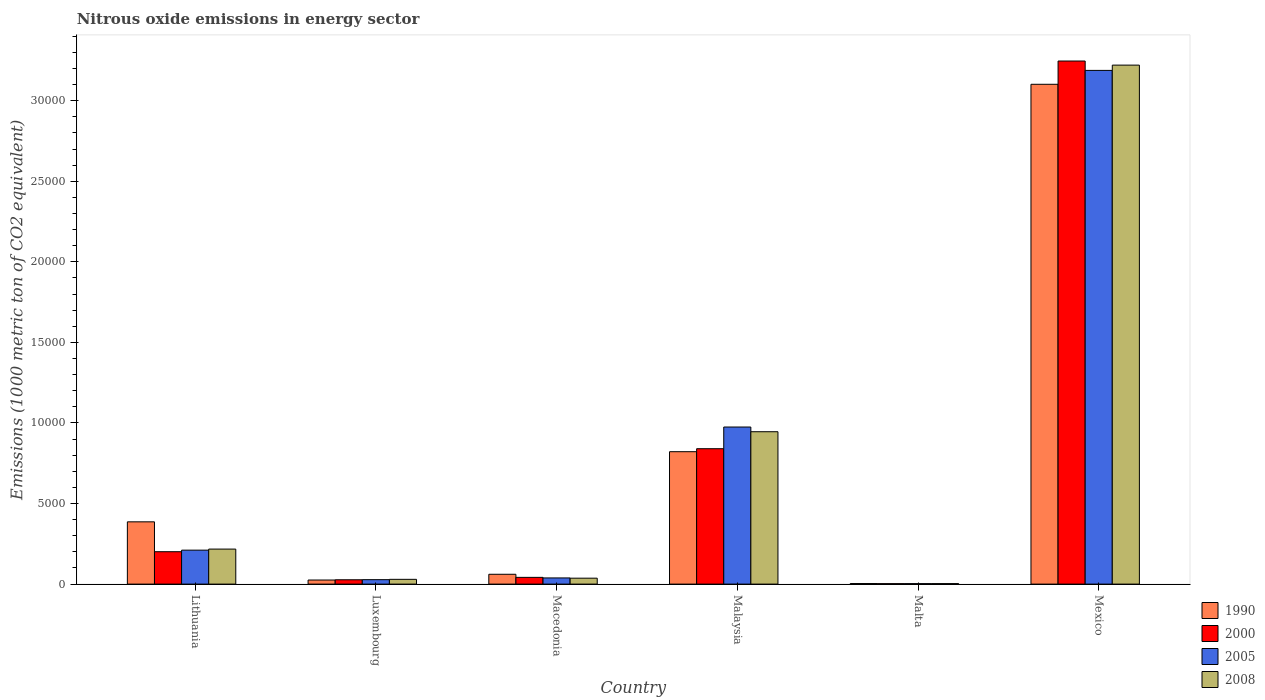How many different coloured bars are there?
Give a very brief answer. 4. In how many cases, is the number of bars for a given country not equal to the number of legend labels?
Your answer should be compact. 0. What is the amount of nitrous oxide emitted in 2000 in Lithuania?
Your answer should be very brief. 2010.8. Across all countries, what is the maximum amount of nitrous oxide emitted in 2005?
Provide a succinct answer. 3.19e+04. Across all countries, what is the minimum amount of nitrous oxide emitted in 2008?
Ensure brevity in your answer.  31.1. In which country was the amount of nitrous oxide emitted in 2008 maximum?
Give a very brief answer. Mexico. In which country was the amount of nitrous oxide emitted in 2008 minimum?
Make the answer very short. Malta. What is the total amount of nitrous oxide emitted in 1990 in the graph?
Make the answer very short. 4.40e+04. What is the difference between the amount of nitrous oxide emitted in 1990 in Malaysia and that in Malta?
Your response must be concise. 8183. What is the difference between the amount of nitrous oxide emitted in 2008 in Malaysia and the amount of nitrous oxide emitted in 1990 in Malta?
Offer a terse response. 9422.6. What is the average amount of nitrous oxide emitted in 2008 per country?
Make the answer very short. 7423.28. What is the difference between the amount of nitrous oxide emitted of/in 2008 and amount of nitrous oxide emitted of/in 2000 in Malaysia?
Offer a very short reply. 1054.4. In how many countries, is the amount of nitrous oxide emitted in 2005 greater than 20000 1000 metric ton?
Your response must be concise. 1. What is the ratio of the amount of nitrous oxide emitted in 2005 in Lithuania to that in Mexico?
Make the answer very short. 0.07. What is the difference between the highest and the second highest amount of nitrous oxide emitted in 1990?
Your response must be concise. -4353. What is the difference between the highest and the lowest amount of nitrous oxide emitted in 2000?
Your answer should be very brief. 3.24e+04. Is it the case that in every country, the sum of the amount of nitrous oxide emitted in 2008 and amount of nitrous oxide emitted in 2000 is greater than the sum of amount of nitrous oxide emitted in 2005 and amount of nitrous oxide emitted in 1990?
Ensure brevity in your answer.  No. What does the 1st bar from the left in Malaysia represents?
Your response must be concise. 1990. What does the 3rd bar from the right in Macedonia represents?
Your response must be concise. 2000. Is it the case that in every country, the sum of the amount of nitrous oxide emitted in 2008 and amount of nitrous oxide emitted in 1990 is greater than the amount of nitrous oxide emitted in 2005?
Your response must be concise. Yes. How many bars are there?
Provide a short and direct response. 24. Are all the bars in the graph horizontal?
Your answer should be compact. No. What is the difference between two consecutive major ticks on the Y-axis?
Provide a succinct answer. 5000. Are the values on the major ticks of Y-axis written in scientific E-notation?
Keep it short and to the point. No. Where does the legend appear in the graph?
Keep it short and to the point. Bottom right. How many legend labels are there?
Your answer should be very brief. 4. How are the legend labels stacked?
Provide a short and direct response. Vertical. What is the title of the graph?
Your answer should be compact. Nitrous oxide emissions in energy sector. What is the label or title of the X-axis?
Provide a short and direct response. Country. What is the label or title of the Y-axis?
Make the answer very short. Emissions (1000 metric ton of CO2 equivalent). What is the Emissions (1000 metric ton of CO2 equivalent) in 1990 in Lithuania?
Give a very brief answer. 3865. What is the Emissions (1000 metric ton of CO2 equivalent) of 2000 in Lithuania?
Your response must be concise. 2010.8. What is the Emissions (1000 metric ton of CO2 equivalent) in 2005 in Lithuania?
Provide a succinct answer. 2107. What is the Emissions (1000 metric ton of CO2 equivalent) of 2008 in Lithuania?
Offer a terse response. 2173.9. What is the Emissions (1000 metric ton of CO2 equivalent) of 1990 in Luxembourg?
Your response must be concise. 253.6. What is the Emissions (1000 metric ton of CO2 equivalent) in 2000 in Luxembourg?
Your answer should be compact. 268.4. What is the Emissions (1000 metric ton of CO2 equivalent) of 2005 in Luxembourg?
Your answer should be very brief. 275.3. What is the Emissions (1000 metric ton of CO2 equivalent) in 2008 in Luxembourg?
Your answer should be very brief. 296.2. What is the Emissions (1000 metric ton of CO2 equivalent) in 1990 in Macedonia?
Your answer should be very brief. 610.4. What is the Emissions (1000 metric ton of CO2 equivalent) of 2000 in Macedonia?
Your answer should be very brief. 418.3. What is the Emissions (1000 metric ton of CO2 equivalent) of 2005 in Macedonia?
Give a very brief answer. 382.8. What is the Emissions (1000 metric ton of CO2 equivalent) of 2008 in Macedonia?
Your answer should be very brief. 368. What is the Emissions (1000 metric ton of CO2 equivalent) in 1990 in Malaysia?
Keep it short and to the point. 8218. What is the Emissions (1000 metric ton of CO2 equivalent) of 2000 in Malaysia?
Ensure brevity in your answer.  8403.2. What is the Emissions (1000 metric ton of CO2 equivalent) of 2005 in Malaysia?
Your answer should be very brief. 9749.3. What is the Emissions (1000 metric ton of CO2 equivalent) of 2008 in Malaysia?
Your answer should be very brief. 9457.6. What is the Emissions (1000 metric ton of CO2 equivalent) of 1990 in Malta?
Offer a terse response. 35. What is the Emissions (1000 metric ton of CO2 equivalent) in 2000 in Malta?
Provide a succinct answer. 28.2. What is the Emissions (1000 metric ton of CO2 equivalent) in 2005 in Malta?
Provide a short and direct response. 28.7. What is the Emissions (1000 metric ton of CO2 equivalent) of 2008 in Malta?
Keep it short and to the point. 31.1. What is the Emissions (1000 metric ton of CO2 equivalent) of 1990 in Mexico?
Make the answer very short. 3.10e+04. What is the Emissions (1000 metric ton of CO2 equivalent) of 2000 in Mexico?
Your response must be concise. 3.25e+04. What is the Emissions (1000 metric ton of CO2 equivalent) of 2005 in Mexico?
Your answer should be compact. 3.19e+04. What is the Emissions (1000 metric ton of CO2 equivalent) of 2008 in Mexico?
Give a very brief answer. 3.22e+04. Across all countries, what is the maximum Emissions (1000 metric ton of CO2 equivalent) in 1990?
Your answer should be very brief. 3.10e+04. Across all countries, what is the maximum Emissions (1000 metric ton of CO2 equivalent) in 2000?
Give a very brief answer. 3.25e+04. Across all countries, what is the maximum Emissions (1000 metric ton of CO2 equivalent) in 2005?
Give a very brief answer. 3.19e+04. Across all countries, what is the maximum Emissions (1000 metric ton of CO2 equivalent) of 2008?
Keep it short and to the point. 3.22e+04. Across all countries, what is the minimum Emissions (1000 metric ton of CO2 equivalent) in 2000?
Make the answer very short. 28.2. Across all countries, what is the minimum Emissions (1000 metric ton of CO2 equivalent) of 2005?
Keep it short and to the point. 28.7. Across all countries, what is the minimum Emissions (1000 metric ton of CO2 equivalent) of 2008?
Offer a very short reply. 31.1. What is the total Emissions (1000 metric ton of CO2 equivalent) of 1990 in the graph?
Keep it short and to the point. 4.40e+04. What is the total Emissions (1000 metric ton of CO2 equivalent) in 2000 in the graph?
Your answer should be compact. 4.36e+04. What is the total Emissions (1000 metric ton of CO2 equivalent) in 2005 in the graph?
Your answer should be compact. 4.44e+04. What is the total Emissions (1000 metric ton of CO2 equivalent) of 2008 in the graph?
Provide a succinct answer. 4.45e+04. What is the difference between the Emissions (1000 metric ton of CO2 equivalent) of 1990 in Lithuania and that in Luxembourg?
Keep it short and to the point. 3611.4. What is the difference between the Emissions (1000 metric ton of CO2 equivalent) in 2000 in Lithuania and that in Luxembourg?
Give a very brief answer. 1742.4. What is the difference between the Emissions (1000 metric ton of CO2 equivalent) in 2005 in Lithuania and that in Luxembourg?
Provide a succinct answer. 1831.7. What is the difference between the Emissions (1000 metric ton of CO2 equivalent) in 2008 in Lithuania and that in Luxembourg?
Your response must be concise. 1877.7. What is the difference between the Emissions (1000 metric ton of CO2 equivalent) in 1990 in Lithuania and that in Macedonia?
Your answer should be compact. 3254.6. What is the difference between the Emissions (1000 metric ton of CO2 equivalent) of 2000 in Lithuania and that in Macedonia?
Ensure brevity in your answer.  1592.5. What is the difference between the Emissions (1000 metric ton of CO2 equivalent) of 2005 in Lithuania and that in Macedonia?
Keep it short and to the point. 1724.2. What is the difference between the Emissions (1000 metric ton of CO2 equivalent) of 2008 in Lithuania and that in Macedonia?
Provide a succinct answer. 1805.9. What is the difference between the Emissions (1000 metric ton of CO2 equivalent) in 1990 in Lithuania and that in Malaysia?
Offer a very short reply. -4353. What is the difference between the Emissions (1000 metric ton of CO2 equivalent) in 2000 in Lithuania and that in Malaysia?
Provide a succinct answer. -6392.4. What is the difference between the Emissions (1000 metric ton of CO2 equivalent) of 2005 in Lithuania and that in Malaysia?
Give a very brief answer. -7642.3. What is the difference between the Emissions (1000 metric ton of CO2 equivalent) in 2008 in Lithuania and that in Malaysia?
Provide a short and direct response. -7283.7. What is the difference between the Emissions (1000 metric ton of CO2 equivalent) in 1990 in Lithuania and that in Malta?
Your answer should be very brief. 3830. What is the difference between the Emissions (1000 metric ton of CO2 equivalent) of 2000 in Lithuania and that in Malta?
Offer a terse response. 1982.6. What is the difference between the Emissions (1000 metric ton of CO2 equivalent) in 2005 in Lithuania and that in Malta?
Your response must be concise. 2078.3. What is the difference between the Emissions (1000 metric ton of CO2 equivalent) in 2008 in Lithuania and that in Malta?
Your answer should be compact. 2142.8. What is the difference between the Emissions (1000 metric ton of CO2 equivalent) of 1990 in Lithuania and that in Mexico?
Ensure brevity in your answer.  -2.72e+04. What is the difference between the Emissions (1000 metric ton of CO2 equivalent) of 2000 in Lithuania and that in Mexico?
Give a very brief answer. -3.05e+04. What is the difference between the Emissions (1000 metric ton of CO2 equivalent) in 2005 in Lithuania and that in Mexico?
Give a very brief answer. -2.98e+04. What is the difference between the Emissions (1000 metric ton of CO2 equivalent) in 2008 in Lithuania and that in Mexico?
Ensure brevity in your answer.  -3.00e+04. What is the difference between the Emissions (1000 metric ton of CO2 equivalent) in 1990 in Luxembourg and that in Macedonia?
Make the answer very short. -356.8. What is the difference between the Emissions (1000 metric ton of CO2 equivalent) of 2000 in Luxembourg and that in Macedonia?
Offer a terse response. -149.9. What is the difference between the Emissions (1000 metric ton of CO2 equivalent) in 2005 in Luxembourg and that in Macedonia?
Offer a very short reply. -107.5. What is the difference between the Emissions (1000 metric ton of CO2 equivalent) of 2008 in Luxembourg and that in Macedonia?
Ensure brevity in your answer.  -71.8. What is the difference between the Emissions (1000 metric ton of CO2 equivalent) in 1990 in Luxembourg and that in Malaysia?
Provide a short and direct response. -7964.4. What is the difference between the Emissions (1000 metric ton of CO2 equivalent) in 2000 in Luxembourg and that in Malaysia?
Provide a succinct answer. -8134.8. What is the difference between the Emissions (1000 metric ton of CO2 equivalent) of 2005 in Luxembourg and that in Malaysia?
Your response must be concise. -9474. What is the difference between the Emissions (1000 metric ton of CO2 equivalent) in 2008 in Luxembourg and that in Malaysia?
Provide a short and direct response. -9161.4. What is the difference between the Emissions (1000 metric ton of CO2 equivalent) of 1990 in Luxembourg and that in Malta?
Your answer should be very brief. 218.6. What is the difference between the Emissions (1000 metric ton of CO2 equivalent) in 2000 in Luxembourg and that in Malta?
Offer a terse response. 240.2. What is the difference between the Emissions (1000 metric ton of CO2 equivalent) in 2005 in Luxembourg and that in Malta?
Provide a succinct answer. 246.6. What is the difference between the Emissions (1000 metric ton of CO2 equivalent) of 2008 in Luxembourg and that in Malta?
Offer a very short reply. 265.1. What is the difference between the Emissions (1000 metric ton of CO2 equivalent) in 1990 in Luxembourg and that in Mexico?
Your answer should be compact. -3.08e+04. What is the difference between the Emissions (1000 metric ton of CO2 equivalent) in 2000 in Luxembourg and that in Mexico?
Your answer should be very brief. -3.22e+04. What is the difference between the Emissions (1000 metric ton of CO2 equivalent) in 2005 in Luxembourg and that in Mexico?
Give a very brief answer. -3.16e+04. What is the difference between the Emissions (1000 metric ton of CO2 equivalent) in 2008 in Luxembourg and that in Mexico?
Offer a very short reply. -3.19e+04. What is the difference between the Emissions (1000 metric ton of CO2 equivalent) of 1990 in Macedonia and that in Malaysia?
Make the answer very short. -7607.6. What is the difference between the Emissions (1000 metric ton of CO2 equivalent) in 2000 in Macedonia and that in Malaysia?
Your answer should be very brief. -7984.9. What is the difference between the Emissions (1000 metric ton of CO2 equivalent) in 2005 in Macedonia and that in Malaysia?
Your answer should be compact. -9366.5. What is the difference between the Emissions (1000 metric ton of CO2 equivalent) of 2008 in Macedonia and that in Malaysia?
Provide a succinct answer. -9089.6. What is the difference between the Emissions (1000 metric ton of CO2 equivalent) of 1990 in Macedonia and that in Malta?
Offer a terse response. 575.4. What is the difference between the Emissions (1000 metric ton of CO2 equivalent) of 2000 in Macedonia and that in Malta?
Provide a short and direct response. 390.1. What is the difference between the Emissions (1000 metric ton of CO2 equivalent) of 2005 in Macedonia and that in Malta?
Keep it short and to the point. 354.1. What is the difference between the Emissions (1000 metric ton of CO2 equivalent) of 2008 in Macedonia and that in Malta?
Offer a terse response. 336.9. What is the difference between the Emissions (1000 metric ton of CO2 equivalent) of 1990 in Macedonia and that in Mexico?
Make the answer very short. -3.04e+04. What is the difference between the Emissions (1000 metric ton of CO2 equivalent) in 2000 in Macedonia and that in Mexico?
Ensure brevity in your answer.  -3.20e+04. What is the difference between the Emissions (1000 metric ton of CO2 equivalent) of 2005 in Macedonia and that in Mexico?
Your answer should be very brief. -3.15e+04. What is the difference between the Emissions (1000 metric ton of CO2 equivalent) of 2008 in Macedonia and that in Mexico?
Your answer should be compact. -3.18e+04. What is the difference between the Emissions (1000 metric ton of CO2 equivalent) of 1990 in Malaysia and that in Malta?
Offer a terse response. 8183. What is the difference between the Emissions (1000 metric ton of CO2 equivalent) in 2000 in Malaysia and that in Malta?
Your answer should be compact. 8375. What is the difference between the Emissions (1000 metric ton of CO2 equivalent) of 2005 in Malaysia and that in Malta?
Provide a short and direct response. 9720.6. What is the difference between the Emissions (1000 metric ton of CO2 equivalent) in 2008 in Malaysia and that in Malta?
Provide a short and direct response. 9426.5. What is the difference between the Emissions (1000 metric ton of CO2 equivalent) in 1990 in Malaysia and that in Mexico?
Offer a very short reply. -2.28e+04. What is the difference between the Emissions (1000 metric ton of CO2 equivalent) in 2000 in Malaysia and that in Mexico?
Provide a short and direct response. -2.41e+04. What is the difference between the Emissions (1000 metric ton of CO2 equivalent) of 2005 in Malaysia and that in Mexico?
Make the answer very short. -2.21e+04. What is the difference between the Emissions (1000 metric ton of CO2 equivalent) of 2008 in Malaysia and that in Mexico?
Give a very brief answer. -2.28e+04. What is the difference between the Emissions (1000 metric ton of CO2 equivalent) of 1990 in Malta and that in Mexico?
Your answer should be compact. -3.10e+04. What is the difference between the Emissions (1000 metric ton of CO2 equivalent) of 2000 in Malta and that in Mexico?
Your answer should be very brief. -3.24e+04. What is the difference between the Emissions (1000 metric ton of CO2 equivalent) of 2005 in Malta and that in Mexico?
Provide a succinct answer. -3.19e+04. What is the difference between the Emissions (1000 metric ton of CO2 equivalent) in 2008 in Malta and that in Mexico?
Make the answer very short. -3.22e+04. What is the difference between the Emissions (1000 metric ton of CO2 equivalent) in 1990 in Lithuania and the Emissions (1000 metric ton of CO2 equivalent) in 2000 in Luxembourg?
Provide a succinct answer. 3596.6. What is the difference between the Emissions (1000 metric ton of CO2 equivalent) in 1990 in Lithuania and the Emissions (1000 metric ton of CO2 equivalent) in 2005 in Luxembourg?
Offer a very short reply. 3589.7. What is the difference between the Emissions (1000 metric ton of CO2 equivalent) in 1990 in Lithuania and the Emissions (1000 metric ton of CO2 equivalent) in 2008 in Luxembourg?
Your answer should be compact. 3568.8. What is the difference between the Emissions (1000 metric ton of CO2 equivalent) of 2000 in Lithuania and the Emissions (1000 metric ton of CO2 equivalent) of 2005 in Luxembourg?
Ensure brevity in your answer.  1735.5. What is the difference between the Emissions (1000 metric ton of CO2 equivalent) in 2000 in Lithuania and the Emissions (1000 metric ton of CO2 equivalent) in 2008 in Luxembourg?
Your response must be concise. 1714.6. What is the difference between the Emissions (1000 metric ton of CO2 equivalent) in 2005 in Lithuania and the Emissions (1000 metric ton of CO2 equivalent) in 2008 in Luxembourg?
Provide a short and direct response. 1810.8. What is the difference between the Emissions (1000 metric ton of CO2 equivalent) of 1990 in Lithuania and the Emissions (1000 metric ton of CO2 equivalent) of 2000 in Macedonia?
Keep it short and to the point. 3446.7. What is the difference between the Emissions (1000 metric ton of CO2 equivalent) in 1990 in Lithuania and the Emissions (1000 metric ton of CO2 equivalent) in 2005 in Macedonia?
Keep it short and to the point. 3482.2. What is the difference between the Emissions (1000 metric ton of CO2 equivalent) in 1990 in Lithuania and the Emissions (1000 metric ton of CO2 equivalent) in 2008 in Macedonia?
Offer a terse response. 3497. What is the difference between the Emissions (1000 metric ton of CO2 equivalent) of 2000 in Lithuania and the Emissions (1000 metric ton of CO2 equivalent) of 2005 in Macedonia?
Offer a very short reply. 1628. What is the difference between the Emissions (1000 metric ton of CO2 equivalent) in 2000 in Lithuania and the Emissions (1000 metric ton of CO2 equivalent) in 2008 in Macedonia?
Provide a short and direct response. 1642.8. What is the difference between the Emissions (1000 metric ton of CO2 equivalent) in 2005 in Lithuania and the Emissions (1000 metric ton of CO2 equivalent) in 2008 in Macedonia?
Offer a terse response. 1739. What is the difference between the Emissions (1000 metric ton of CO2 equivalent) of 1990 in Lithuania and the Emissions (1000 metric ton of CO2 equivalent) of 2000 in Malaysia?
Offer a very short reply. -4538.2. What is the difference between the Emissions (1000 metric ton of CO2 equivalent) in 1990 in Lithuania and the Emissions (1000 metric ton of CO2 equivalent) in 2005 in Malaysia?
Your answer should be very brief. -5884.3. What is the difference between the Emissions (1000 metric ton of CO2 equivalent) of 1990 in Lithuania and the Emissions (1000 metric ton of CO2 equivalent) of 2008 in Malaysia?
Offer a terse response. -5592.6. What is the difference between the Emissions (1000 metric ton of CO2 equivalent) of 2000 in Lithuania and the Emissions (1000 metric ton of CO2 equivalent) of 2005 in Malaysia?
Your answer should be compact. -7738.5. What is the difference between the Emissions (1000 metric ton of CO2 equivalent) of 2000 in Lithuania and the Emissions (1000 metric ton of CO2 equivalent) of 2008 in Malaysia?
Provide a short and direct response. -7446.8. What is the difference between the Emissions (1000 metric ton of CO2 equivalent) in 2005 in Lithuania and the Emissions (1000 metric ton of CO2 equivalent) in 2008 in Malaysia?
Your answer should be very brief. -7350.6. What is the difference between the Emissions (1000 metric ton of CO2 equivalent) in 1990 in Lithuania and the Emissions (1000 metric ton of CO2 equivalent) in 2000 in Malta?
Offer a very short reply. 3836.8. What is the difference between the Emissions (1000 metric ton of CO2 equivalent) in 1990 in Lithuania and the Emissions (1000 metric ton of CO2 equivalent) in 2005 in Malta?
Provide a short and direct response. 3836.3. What is the difference between the Emissions (1000 metric ton of CO2 equivalent) in 1990 in Lithuania and the Emissions (1000 metric ton of CO2 equivalent) in 2008 in Malta?
Your answer should be compact. 3833.9. What is the difference between the Emissions (1000 metric ton of CO2 equivalent) in 2000 in Lithuania and the Emissions (1000 metric ton of CO2 equivalent) in 2005 in Malta?
Keep it short and to the point. 1982.1. What is the difference between the Emissions (1000 metric ton of CO2 equivalent) in 2000 in Lithuania and the Emissions (1000 metric ton of CO2 equivalent) in 2008 in Malta?
Provide a short and direct response. 1979.7. What is the difference between the Emissions (1000 metric ton of CO2 equivalent) in 2005 in Lithuania and the Emissions (1000 metric ton of CO2 equivalent) in 2008 in Malta?
Give a very brief answer. 2075.9. What is the difference between the Emissions (1000 metric ton of CO2 equivalent) in 1990 in Lithuania and the Emissions (1000 metric ton of CO2 equivalent) in 2000 in Mexico?
Keep it short and to the point. -2.86e+04. What is the difference between the Emissions (1000 metric ton of CO2 equivalent) of 1990 in Lithuania and the Emissions (1000 metric ton of CO2 equivalent) of 2005 in Mexico?
Keep it short and to the point. -2.80e+04. What is the difference between the Emissions (1000 metric ton of CO2 equivalent) in 1990 in Lithuania and the Emissions (1000 metric ton of CO2 equivalent) in 2008 in Mexico?
Provide a succinct answer. -2.83e+04. What is the difference between the Emissions (1000 metric ton of CO2 equivalent) in 2000 in Lithuania and the Emissions (1000 metric ton of CO2 equivalent) in 2005 in Mexico?
Provide a succinct answer. -2.99e+04. What is the difference between the Emissions (1000 metric ton of CO2 equivalent) in 2000 in Lithuania and the Emissions (1000 metric ton of CO2 equivalent) in 2008 in Mexico?
Make the answer very short. -3.02e+04. What is the difference between the Emissions (1000 metric ton of CO2 equivalent) in 2005 in Lithuania and the Emissions (1000 metric ton of CO2 equivalent) in 2008 in Mexico?
Give a very brief answer. -3.01e+04. What is the difference between the Emissions (1000 metric ton of CO2 equivalent) of 1990 in Luxembourg and the Emissions (1000 metric ton of CO2 equivalent) of 2000 in Macedonia?
Keep it short and to the point. -164.7. What is the difference between the Emissions (1000 metric ton of CO2 equivalent) in 1990 in Luxembourg and the Emissions (1000 metric ton of CO2 equivalent) in 2005 in Macedonia?
Keep it short and to the point. -129.2. What is the difference between the Emissions (1000 metric ton of CO2 equivalent) of 1990 in Luxembourg and the Emissions (1000 metric ton of CO2 equivalent) of 2008 in Macedonia?
Your answer should be compact. -114.4. What is the difference between the Emissions (1000 metric ton of CO2 equivalent) of 2000 in Luxembourg and the Emissions (1000 metric ton of CO2 equivalent) of 2005 in Macedonia?
Your answer should be very brief. -114.4. What is the difference between the Emissions (1000 metric ton of CO2 equivalent) in 2000 in Luxembourg and the Emissions (1000 metric ton of CO2 equivalent) in 2008 in Macedonia?
Your answer should be compact. -99.6. What is the difference between the Emissions (1000 metric ton of CO2 equivalent) in 2005 in Luxembourg and the Emissions (1000 metric ton of CO2 equivalent) in 2008 in Macedonia?
Offer a terse response. -92.7. What is the difference between the Emissions (1000 metric ton of CO2 equivalent) of 1990 in Luxembourg and the Emissions (1000 metric ton of CO2 equivalent) of 2000 in Malaysia?
Give a very brief answer. -8149.6. What is the difference between the Emissions (1000 metric ton of CO2 equivalent) in 1990 in Luxembourg and the Emissions (1000 metric ton of CO2 equivalent) in 2005 in Malaysia?
Offer a terse response. -9495.7. What is the difference between the Emissions (1000 metric ton of CO2 equivalent) of 1990 in Luxembourg and the Emissions (1000 metric ton of CO2 equivalent) of 2008 in Malaysia?
Give a very brief answer. -9204. What is the difference between the Emissions (1000 metric ton of CO2 equivalent) in 2000 in Luxembourg and the Emissions (1000 metric ton of CO2 equivalent) in 2005 in Malaysia?
Make the answer very short. -9480.9. What is the difference between the Emissions (1000 metric ton of CO2 equivalent) in 2000 in Luxembourg and the Emissions (1000 metric ton of CO2 equivalent) in 2008 in Malaysia?
Make the answer very short. -9189.2. What is the difference between the Emissions (1000 metric ton of CO2 equivalent) in 2005 in Luxembourg and the Emissions (1000 metric ton of CO2 equivalent) in 2008 in Malaysia?
Provide a succinct answer. -9182.3. What is the difference between the Emissions (1000 metric ton of CO2 equivalent) in 1990 in Luxembourg and the Emissions (1000 metric ton of CO2 equivalent) in 2000 in Malta?
Give a very brief answer. 225.4. What is the difference between the Emissions (1000 metric ton of CO2 equivalent) in 1990 in Luxembourg and the Emissions (1000 metric ton of CO2 equivalent) in 2005 in Malta?
Provide a succinct answer. 224.9. What is the difference between the Emissions (1000 metric ton of CO2 equivalent) in 1990 in Luxembourg and the Emissions (1000 metric ton of CO2 equivalent) in 2008 in Malta?
Your response must be concise. 222.5. What is the difference between the Emissions (1000 metric ton of CO2 equivalent) in 2000 in Luxembourg and the Emissions (1000 metric ton of CO2 equivalent) in 2005 in Malta?
Offer a very short reply. 239.7. What is the difference between the Emissions (1000 metric ton of CO2 equivalent) of 2000 in Luxembourg and the Emissions (1000 metric ton of CO2 equivalent) of 2008 in Malta?
Offer a very short reply. 237.3. What is the difference between the Emissions (1000 metric ton of CO2 equivalent) in 2005 in Luxembourg and the Emissions (1000 metric ton of CO2 equivalent) in 2008 in Malta?
Keep it short and to the point. 244.2. What is the difference between the Emissions (1000 metric ton of CO2 equivalent) in 1990 in Luxembourg and the Emissions (1000 metric ton of CO2 equivalent) in 2000 in Mexico?
Your answer should be very brief. -3.22e+04. What is the difference between the Emissions (1000 metric ton of CO2 equivalent) of 1990 in Luxembourg and the Emissions (1000 metric ton of CO2 equivalent) of 2005 in Mexico?
Offer a very short reply. -3.16e+04. What is the difference between the Emissions (1000 metric ton of CO2 equivalent) of 1990 in Luxembourg and the Emissions (1000 metric ton of CO2 equivalent) of 2008 in Mexico?
Give a very brief answer. -3.20e+04. What is the difference between the Emissions (1000 metric ton of CO2 equivalent) in 2000 in Luxembourg and the Emissions (1000 metric ton of CO2 equivalent) in 2005 in Mexico?
Provide a succinct answer. -3.16e+04. What is the difference between the Emissions (1000 metric ton of CO2 equivalent) of 2000 in Luxembourg and the Emissions (1000 metric ton of CO2 equivalent) of 2008 in Mexico?
Your answer should be very brief. -3.19e+04. What is the difference between the Emissions (1000 metric ton of CO2 equivalent) in 2005 in Luxembourg and the Emissions (1000 metric ton of CO2 equivalent) in 2008 in Mexico?
Provide a short and direct response. -3.19e+04. What is the difference between the Emissions (1000 metric ton of CO2 equivalent) in 1990 in Macedonia and the Emissions (1000 metric ton of CO2 equivalent) in 2000 in Malaysia?
Your response must be concise. -7792.8. What is the difference between the Emissions (1000 metric ton of CO2 equivalent) in 1990 in Macedonia and the Emissions (1000 metric ton of CO2 equivalent) in 2005 in Malaysia?
Keep it short and to the point. -9138.9. What is the difference between the Emissions (1000 metric ton of CO2 equivalent) of 1990 in Macedonia and the Emissions (1000 metric ton of CO2 equivalent) of 2008 in Malaysia?
Your answer should be very brief. -8847.2. What is the difference between the Emissions (1000 metric ton of CO2 equivalent) in 2000 in Macedonia and the Emissions (1000 metric ton of CO2 equivalent) in 2005 in Malaysia?
Provide a short and direct response. -9331. What is the difference between the Emissions (1000 metric ton of CO2 equivalent) in 2000 in Macedonia and the Emissions (1000 metric ton of CO2 equivalent) in 2008 in Malaysia?
Offer a terse response. -9039.3. What is the difference between the Emissions (1000 metric ton of CO2 equivalent) of 2005 in Macedonia and the Emissions (1000 metric ton of CO2 equivalent) of 2008 in Malaysia?
Your answer should be compact. -9074.8. What is the difference between the Emissions (1000 metric ton of CO2 equivalent) in 1990 in Macedonia and the Emissions (1000 metric ton of CO2 equivalent) in 2000 in Malta?
Provide a short and direct response. 582.2. What is the difference between the Emissions (1000 metric ton of CO2 equivalent) of 1990 in Macedonia and the Emissions (1000 metric ton of CO2 equivalent) of 2005 in Malta?
Offer a very short reply. 581.7. What is the difference between the Emissions (1000 metric ton of CO2 equivalent) of 1990 in Macedonia and the Emissions (1000 metric ton of CO2 equivalent) of 2008 in Malta?
Ensure brevity in your answer.  579.3. What is the difference between the Emissions (1000 metric ton of CO2 equivalent) of 2000 in Macedonia and the Emissions (1000 metric ton of CO2 equivalent) of 2005 in Malta?
Offer a terse response. 389.6. What is the difference between the Emissions (1000 metric ton of CO2 equivalent) in 2000 in Macedonia and the Emissions (1000 metric ton of CO2 equivalent) in 2008 in Malta?
Your answer should be compact. 387.2. What is the difference between the Emissions (1000 metric ton of CO2 equivalent) of 2005 in Macedonia and the Emissions (1000 metric ton of CO2 equivalent) of 2008 in Malta?
Give a very brief answer. 351.7. What is the difference between the Emissions (1000 metric ton of CO2 equivalent) of 1990 in Macedonia and the Emissions (1000 metric ton of CO2 equivalent) of 2000 in Mexico?
Ensure brevity in your answer.  -3.19e+04. What is the difference between the Emissions (1000 metric ton of CO2 equivalent) of 1990 in Macedonia and the Emissions (1000 metric ton of CO2 equivalent) of 2005 in Mexico?
Provide a succinct answer. -3.13e+04. What is the difference between the Emissions (1000 metric ton of CO2 equivalent) in 1990 in Macedonia and the Emissions (1000 metric ton of CO2 equivalent) in 2008 in Mexico?
Your response must be concise. -3.16e+04. What is the difference between the Emissions (1000 metric ton of CO2 equivalent) of 2000 in Macedonia and the Emissions (1000 metric ton of CO2 equivalent) of 2005 in Mexico?
Your response must be concise. -3.15e+04. What is the difference between the Emissions (1000 metric ton of CO2 equivalent) of 2000 in Macedonia and the Emissions (1000 metric ton of CO2 equivalent) of 2008 in Mexico?
Ensure brevity in your answer.  -3.18e+04. What is the difference between the Emissions (1000 metric ton of CO2 equivalent) of 2005 in Macedonia and the Emissions (1000 metric ton of CO2 equivalent) of 2008 in Mexico?
Offer a terse response. -3.18e+04. What is the difference between the Emissions (1000 metric ton of CO2 equivalent) in 1990 in Malaysia and the Emissions (1000 metric ton of CO2 equivalent) in 2000 in Malta?
Keep it short and to the point. 8189.8. What is the difference between the Emissions (1000 metric ton of CO2 equivalent) of 1990 in Malaysia and the Emissions (1000 metric ton of CO2 equivalent) of 2005 in Malta?
Offer a terse response. 8189.3. What is the difference between the Emissions (1000 metric ton of CO2 equivalent) of 1990 in Malaysia and the Emissions (1000 metric ton of CO2 equivalent) of 2008 in Malta?
Your answer should be very brief. 8186.9. What is the difference between the Emissions (1000 metric ton of CO2 equivalent) of 2000 in Malaysia and the Emissions (1000 metric ton of CO2 equivalent) of 2005 in Malta?
Provide a short and direct response. 8374.5. What is the difference between the Emissions (1000 metric ton of CO2 equivalent) in 2000 in Malaysia and the Emissions (1000 metric ton of CO2 equivalent) in 2008 in Malta?
Your answer should be compact. 8372.1. What is the difference between the Emissions (1000 metric ton of CO2 equivalent) of 2005 in Malaysia and the Emissions (1000 metric ton of CO2 equivalent) of 2008 in Malta?
Provide a succinct answer. 9718.2. What is the difference between the Emissions (1000 metric ton of CO2 equivalent) in 1990 in Malaysia and the Emissions (1000 metric ton of CO2 equivalent) in 2000 in Mexico?
Offer a terse response. -2.42e+04. What is the difference between the Emissions (1000 metric ton of CO2 equivalent) in 1990 in Malaysia and the Emissions (1000 metric ton of CO2 equivalent) in 2005 in Mexico?
Your answer should be compact. -2.37e+04. What is the difference between the Emissions (1000 metric ton of CO2 equivalent) of 1990 in Malaysia and the Emissions (1000 metric ton of CO2 equivalent) of 2008 in Mexico?
Offer a terse response. -2.40e+04. What is the difference between the Emissions (1000 metric ton of CO2 equivalent) in 2000 in Malaysia and the Emissions (1000 metric ton of CO2 equivalent) in 2005 in Mexico?
Your response must be concise. -2.35e+04. What is the difference between the Emissions (1000 metric ton of CO2 equivalent) of 2000 in Malaysia and the Emissions (1000 metric ton of CO2 equivalent) of 2008 in Mexico?
Your response must be concise. -2.38e+04. What is the difference between the Emissions (1000 metric ton of CO2 equivalent) in 2005 in Malaysia and the Emissions (1000 metric ton of CO2 equivalent) in 2008 in Mexico?
Your response must be concise. -2.25e+04. What is the difference between the Emissions (1000 metric ton of CO2 equivalent) of 1990 in Malta and the Emissions (1000 metric ton of CO2 equivalent) of 2000 in Mexico?
Provide a short and direct response. -3.24e+04. What is the difference between the Emissions (1000 metric ton of CO2 equivalent) in 1990 in Malta and the Emissions (1000 metric ton of CO2 equivalent) in 2005 in Mexico?
Your answer should be very brief. -3.18e+04. What is the difference between the Emissions (1000 metric ton of CO2 equivalent) of 1990 in Malta and the Emissions (1000 metric ton of CO2 equivalent) of 2008 in Mexico?
Your answer should be very brief. -3.22e+04. What is the difference between the Emissions (1000 metric ton of CO2 equivalent) of 2000 in Malta and the Emissions (1000 metric ton of CO2 equivalent) of 2005 in Mexico?
Ensure brevity in your answer.  -3.19e+04. What is the difference between the Emissions (1000 metric ton of CO2 equivalent) in 2000 in Malta and the Emissions (1000 metric ton of CO2 equivalent) in 2008 in Mexico?
Ensure brevity in your answer.  -3.22e+04. What is the difference between the Emissions (1000 metric ton of CO2 equivalent) in 2005 in Malta and the Emissions (1000 metric ton of CO2 equivalent) in 2008 in Mexico?
Provide a succinct answer. -3.22e+04. What is the average Emissions (1000 metric ton of CO2 equivalent) in 1990 per country?
Offer a very short reply. 7334.07. What is the average Emissions (1000 metric ton of CO2 equivalent) of 2000 per country?
Provide a succinct answer. 7265.88. What is the average Emissions (1000 metric ton of CO2 equivalent) of 2005 per country?
Your answer should be very brief. 7404.63. What is the average Emissions (1000 metric ton of CO2 equivalent) in 2008 per country?
Offer a very short reply. 7423.28. What is the difference between the Emissions (1000 metric ton of CO2 equivalent) of 1990 and Emissions (1000 metric ton of CO2 equivalent) of 2000 in Lithuania?
Give a very brief answer. 1854.2. What is the difference between the Emissions (1000 metric ton of CO2 equivalent) of 1990 and Emissions (1000 metric ton of CO2 equivalent) of 2005 in Lithuania?
Make the answer very short. 1758. What is the difference between the Emissions (1000 metric ton of CO2 equivalent) of 1990 and Emissions (1000 metric ton of CO2 equivalent) of 2008 in Lithuania?
Provide a short and direct response. 1691.1. What is the difference between the Emissions (1000 metric ton of CO2 equivalent) in 2000 and Emissions (1000 metric ton of CO2 equivalent) in 2005 in Lithuania?
Provide a short and direct response. -96.2. What is the difference between the Emissions (1000 metric ton of CO2 equivalent) in 2000 and Emissions (1000 metric ton of CO2 equivalent) in 2008 in Lithuania?
Your response must be concise. -163.1. What is the difference between the Emissions (1000 metric ton of CO2 equivalent) of 2005 and Emissions (1000 metric ton of CO2 equivalent) of 2008 in Lithuania?
Your response must be concise. -66.9. What is the difference between the Emissions (1000 metric ton of CO2 equivalent) of 1990 and Emissions (1000 metric ton of CO2 equivalent) of 2000 in Luxembourg?
Make the answer very short. -14.8. What is the difference between the Emissions (1000 metric ton of CO2 equivalent) in 1990 and Emissions (1000 metric ton of CO2 equivalent) in 2005 in Luxembourg?
Offer a terse response. -21.7. What is the difference between the Emissions (1000 metric ton of CO2 equivalent) in 1990 and Emissions (1000 metric ton of CO2 equivalent) in 2008 in Luxembourg?
Make the answer very short. -42.6. What is the difference between the Emissions (1000 metric ton of CO2 equivalent) of 2000 and Emissions (1000 metric ton of CO2 equivalent) of 2005 in Luxembourg?
Your answer should be very brief. -6.9. What is the difference between the Emissions (1000 metric ton of CO2 equivalent) of 2000 and Emissions (1000 metric ton of CO2 equivalent) of 2008 in Luxembourg?
Provide a succinct answer. -27.8. What is the difference between the Emissions (1000 metric ton of CO2 equivalent) in 2005 and Emissions (1000 metric ton of CO2 equivalent) in 2008 in Luxembourg?
Make the answer very short. -20.9. What is the difference between the Emissions (1000 metric ton of CO2 equivalent) of 1990 and Emissions (1000 metric ton of CO2 equivalent) of 2000 in Macedonia?
Make the answer very short. 192.1. What is the difference between the Emissions (1000 metric ton of CO2 equivalent) in 1990 and Emissions (1000 metric ton of CO2 equivalent) in 2005 in Macedonia?
Provide a short and direct response. 227.6. What is the difference between the Emissions (1000 metric ton of CO2 equivalent) in 1990 and Emissions (1000 metric ton of CO2 equivalent) in 2008 in Macedonia?
Provide a succinct answer. 242.4. What is the difference between the Emissions (1000 metric ton of CO2 equivalent) of 2000 and Emissions (1000 metric ton of CO2 equivalent) of 2005 in Macedonia?
Ensure brevity in your answer.  35.5. What is the difference between the Emissions (1000 metric ton of CO2 equivalent) of 2000 and Emissions (1000 metric ton of CO2 equivalent) of 2008 in Macedonia?
Provide a short and direct response. 50.3. What is the difference between the Emissions (1000 metric ton of CO2 equivalent) of 1990 and Emissions (1000 metric ton of CO2 equivalent) of 2000 in Malaysia?
Your response must be concise. -185.2. What is the difference between the Emissions (1000 metric ton of CO2 equivalent) of 1990 and Emissions (1000 metric ton of CO2 equivalent) of 2005 in Malaysia?
Your answer should be very brief. -1531.3. What is the difference between the Emissions (1000 metric ton of CO2 equivalent) of 1990 and Emissions (1000 metric ton of CO2 equivalent) of 2008 in Malaysia?
Offer a terse response. -1239.6. What is the difference between the Emissions (1000 metric ton of CO2 equivalent) in 2000 and Emissions (1000 metric ton of CO2 equivalent) in 2005 in Malaysia?
Provide a short and direct response. -1346.1. What is the difference between the Emissions (1000 metric ton of CO2 equivalent) in 2000 and Emissions (1000 metric ton of CO2 equivalent) in 2008 in Malaysia?
Make the answer very short. -1054.4. What is the difference between the Emissions (1000 metric ton of CO2 equivalent) in 2005 and Emissions (1000 metric ton of CO2 equivalent) in 2008 in Malaysia?
Make the answer very short. 291.7. What is the difference between the Emissions (1000 metric ton of CO2 equivalent) in 1990 and Emissions (1000 metric ton of CO2 equivalent) in 2008 in Malta?
Your answer should be very brief. 3.9. What is the difference between the Emissions (1000 metric ton of CO2 equivalent) in 2000 and Emissions (1000 metric ton of CO2 equivalent) in 2005 in Malta?
Ensure brevity in your answer.  -0.5. What is the difference between the Emissions (1000 metric ton of CO2 equivalent) of 2005 and Emissions (1000 metric ton of CO2 equivalent) of 2008 in Malta?
Provide a succinct answer. -2.4. What is the difference between the Emissions (1000 metric ton of CO2 equivalent) in 1990 and Emissions (1000 metric ton of CO2 equivalent) in 2000 in Mexico?
Give a very brief answer. -1444. What is the difference between the Emissions (1000 metric ton of CO2 equivalent) of 1990 and Emissions (1000 metric ton of CO2 equivalent) of 2005 in Mexico?
Offer a very short reply. -862.3. What is the difference between the Emissions (1000 metric ton of CO2 equivalent) in 1990 and Emissions (1000 metric ton of CO2 equivalent) in 2008 in Mexico?
Provide a succinct answer. -1190.5. What is the difference between the Emissions (1000 metric ton of CO2 equivalent) of 2000 and Emissions (1000 metric ton of CO2 equivalent) of 2005 in Mexico?
Make the answer very short. 581.7. What is the difference between the Emissions (1000 metric ton of CO2 equivalent) in 2000 and Emissions (1000 metric ton of CO2 equivalent) in 2008 in Mexico?
Ensure brevity in your answer.  253.5. What is the difference between the Emissions (1000 metric ton of CO2 equivalent) in 2005 and Emissions (1000 metric ton of CO2 equivalent) in 2008 in Mexico?
Keep it short and to the point. -328.2. What is the ratio of the Emissions (1000 metric ton of CO2 equivalent) of 1990 in Lithuania to that in Luxembourg?
Offer a very short reply. 15.24. What is the ratio of the Emissions (1000 metric ton of CO2 equivalent) of 2000 in Lithuania to that in Luxembourg?
Provide a succinct answer. 7.49. What is the ratio of the Emissions (1000 metric ton of CO2 equivalent) in 2005 in Lithuania to that in Luxembourg?
Give a very brief answer. 7.65. What is the ratio of the Emissions (1000 metric ton of CO2 equivalent) in 2008 in Lithuania to that in Luxembourg?
Give a very brief answer. 7.34. What is the ratio of the Emissions (1000 metric ton of CO2 equivalent) of 1990 in Lithuania to that in Macedonia?
Provide a short and direct response. 6.33. What is the ratio of the Emissions (1000 metric ton of CO2 equivalent) in 2000 in Lithuania to that in Macedonia?
Make the answer very short. 4.81. What is the ratio of the Emissions (1000 metric ton of CO2 equivalent) in 2005 in Lithuania to that in Macedonia?
Offer a very short reply. 5.5. What is the ratio of the Emissions (1000 metric ton of CO2 equivalent) in 2008 in Lithuania to that in Macedonia?
Your answer should be very brief. 5.91. What is the ratio of the Emissions (1000 metric ton of CO2 equivalent) in 1990 in Lithuania to that in Malaysia?
Your answer should be compact. 0.47. What is the ratio of the Emissions (1000 metric ton of CO2 equivalent) of 2000 in Lithuania to that in Malaysia?
Your response must be concise. 0.24. What is the ratio of the Emissions (1000 metric ton of CO2 equivalent) in 2005 in Lithuania to that in Malaysia?
Your answer should be compact. 0.22. What is the ratio of the Emissions (1000 metric ton of CO2 equivalent) in 2008 in Lithuania to that in Malaysia?
Your answer should be compact. 0.23. What is the ratio of the Emissions (1000 metric ton of CO2 equivalent) of 1990 in Lithuania to that in Malta?
Offer a very short reply. 110.43. What is the ratio of the Emissions (1000 metric ton of CO2 equivalent) of 2000 in Lithuania to that in Malta?
Provide a succinct answer. 71.31. What is the ratio of the Emissions (1000 metric ton of CO2 equivalent) of 2005 in Lithuania to that in Malta?
Keep it short and to the point. 73.41. What is the ratio of the Emissions (1000 metric ton of CO2 equivalent) of 2008 in Lithuania to that in Malta?
Keep it short and to the point. 69.9. What is the ratio of the Emissions (1000 metric ton of CO2 equivalent) of 1990 in Lithuania to that in Mexico?
Your answer should be compact. 0.12. What is the ratio of the Emissions (1000 metric ton of CO2 equivalent) in 2000 in Lithuania to that in Mexico?
Provide a short and direct response. 0.06. What is the ratio of the Emissions (1000 metric ton of CO2 equivalent) in 2005 in Lithuania to that in Mexico?
Provide a short and direct response. 0.07. What is the ratio of the Emissions (1000 metric ton of CO2 equivalent) in 2008 in Lithuania to that in Mexico?
Provide a short and direct response. 0.07. What is the ratio of the Emissions (1000 metric ton of CO2 equivalent) in 1990 in Luxembourg to that in Macedonia?
Offer a terse response. 0.42. What is the ratio of the Emissions (1000 metric ton of CO2 equivalent) of 2000 in Luxembourg to that in Macedonia?
Keep it short and to the point. 0.64. What is the ratio of the Emissions (1000 metric ton of CO2 equivalent) in 2005 in Luxembourg to that in Macedonia?
Offer a terse response. 0.72. What is the ratio of the Emissions (1000 metric ton of CO2 equivalent) in 2008 in Luxembourg to that in Macedonia?
Your answer should be very brief. 0.8. What is the ratio of the Emissions (1000 metric ton of CO2 equivalent) of 1990 in Luxembourg to that in Malaysia?
Provide a succinct answer. 0.03. What is the ratio of the Emissions (1000 metric ton of CO2 equivalent) of 2000 in Luxembourg to that in Malaysia?
Offer a very short reply. 0.03. What is the ratio of the Emissions (1000 metric ton of CO2 equivalent) of 2005 in Luxembourg to that in Malaysia?
Give a very brief answer. 0.03. What is the ratio of the Emissions (1000 metric ton of CO2 equivalent) of 2008 in Luxembourg to that in Malaysia?
Provide a short and direct response. 0.03. What is the ratio of the Emissions (1000 metric ton of CO2 equivalent) in 1990 in Luxembourg to that in Malta?
Keep it short and to the point. 7.25. What is the ratio of the Emissions (1000 metric ton of CO2 equivalent) in 2000 in Luxembourg to that in Malta?
Offer a terse response. 9.52. What is the ratio of the Emissions (1000 metric ton of CO2 equivalent) of 2005 in Luxembourg to that in Malta?
Keep it short and to the point. 9.59. What is the ratio of the Emissions (1000 metric ton of CO2 equivalent) of 2008 in Luxembourg to that in Malta?
Provide a short and direct response. 9.52. What is the ratio of the Emissions (1000 metric ton of CO2 equivalent) in 1990 in Luxembourg to that in Mexico?
Keep it short and to the point. 0.01. What is the ratio of the Emissions (1000 metric ton of CO2 equivalent) of 2000 in Luxembourg to that in Mexico?
Give a very brief answer. 0.01. What is the ratio of the Emissions (1000 metric ton of CO2 equivalent) in 2005 in Luxembourg to that in Mexico?
Make the answer very short. 0.01. What is the ratio of the Emissions (1000 metric ton of CO2 equivalent) in 2008 in Luxembourg to that in Mexico?
Offer a terse response. 0.01. What is the ratio of the Emissions (1000 metric ton of CO2 equivalent) of 1990 in Macedonia to that in Malaysia?
Keep it short and to the point. 0.07. What is the ratio of the Emissions (1000 metric ton of CO2 equivalent) of 2000 in Macedonia to that in Malaysia?
Give a very brief answer. 0.05. What is the ratio of the Emissions (1000 metric ton of CO2 equivalent) in 2005 in Macedonia to that in Malaysia?
Make the answer very short. 0.04. What is the ratio of the Emissions (1000 metric ton of CO2 equivalent) in 2008 in Macedonia to that in Malaysia?
Make the answer very short. 0.04. What is the ratio of the Emissions (1000 metric ton of CO2 equivalent) of 1990 in Macedonia to that in Malta?
Provide a short and direct response. 17.44. What is the ratio of the Emissions (1000 metric ton of CO2 equivalent) in 2000 in Macedonia to that in Malta?
Ensure brevity in your answer.  14.83. What is the ratio of the Emissions (1000 metric ton of CO2 equivalent) of 2005 in Macedonia to that in Malta?
Provide a succinct answer. 13.34. What is the ratio of the Emissions (1000 metric ton of CO2 equivalent) in 2008 in Macedonia to that in Malta?
Make the answer very short. 11.83. What is the ratio of the Emissions (1000 metric ton of CO2 equivalent) in 1990 in Macedonia to that in Mexico?
Offer a terse response. 0.02. What is the ratio of the Emissions (1000 metric ton of CO2 equivalent) of 2000 in Macedonia to that in Mexico?
Make the answer very short. 0.01. What is the ratio of the Emissions (1000 metric ton of CO2 equivalent) of 2005 in Macedonia to that in Mexico?
Your answer should be very brief. 0.01. What is the ratio of the Emissions (1000 metric ton of CO2 equivalent) of 2008 in Macedonia to that in Mexico?
Offer a terse response. 0.01. What is the ratio of the Emissions (1000 metric ton of CO2 equivalent) in 1990 in Malaysia to that in Malta?
Offer a very short reply. 234.8. What is the ratio of the Emissions (1000 metric ton of CO2 equivalent) of 2000 in Malaysia to that in Malta?
Your answer should be very brief. 297.99. What is the ratio of the Emissions (1000 metric ton of CO2 equivalent) in 2005 in Malaysia to that in Malta?
Your answer should be compact. 339.7. What is the ratio of the Emissions (1000 metric ton of CO2 equivalent) of 2008 in Malaysia to that in Malta?
Ensure brevity in your answer.  304.1. What is the ratio of the Emissions (1000 metric ton of CO2 equivalent) in 1990 in Malaysia to that in Mexico?
Ensure brevity in your answer.  0.26. What is the ratio of the Emissions (1000 metric ton of CO2 equivalent) of 2000 in Malaysia to that in Mexico?
Your response must be concise. 0.26. What is the ratio of the Emissions (1000 metric ton of CO2 equivalent) of 2005 in Malaysia to that in Mexico?
Provide a succinct answer. 0.31. What is the ratio of the Emissions (1000 metric ton of CO2 equivalent) of 2008 in Malaysia to that in Mexico?
Give a very brief answer. 0.29. What is the ratio of the Emissions (1000 metric ton of CO2 equivalent) of 1990 in Malta to that in Mexico?
Your response must be concise. 0. What is the ratio of the Emissions (1000 metric ton of CO2 equivalent) in 2000 in Malta to that in Mexico?
Keep it short and to the point. 0. What is the ratio of the Emissions (1000 metric ton of CO2 equivalent) of 2005 in Malta to that in Mexico?
Offer a terse response. 0. What is the ratio of the Emissions (1000 metric ton of CO2 equivalent) of 2008 in Malta to that in Mexico?
Your answer should be compact. 0. What is the difference between the highest and the second highest Emissions (1000 metric ton of CO2 equivalent) of 1990?
Provide a succinct answer. 2.28e+04. What is the difference between the highest and the second highest Emissions (1000 metric ton of CO2 equivalent) in 2000?
Your answer should be very brief. 2.41e+04. What is the difference between the highest and the second highest Emissions (1000 metric ton of CO2 equivalent) of 2005?
Your response must be concise. 2.21e+04. What is the difference between the highest and the second highest Emissions (1000 metric ton of CO2 equivalent) in 2008?
Keep it short and to the point. 2.28e+04. What is the difference between the highest and the lowest Emissions (1000 metric ton of CO2 equivalent) in 1990?
Provide a succinct answer. 3.10e+04. What is the difference between the highest and the lowest Emissions (1000 metric ton of CO2 equivalent) in 2000?
Your answer should be compact. 3.24e+04. What is the difference between the highest and the lowest Emissions (1000 metric ton of CO2 equivalent) of 2005?
Your answer should be very brief. 3.19e+04. What is the difference between the highest and the lowest Emissions (1000 metric ton of CO2 equivalent) of 2008?
Your answer should be very brief. 3.22e+04. 